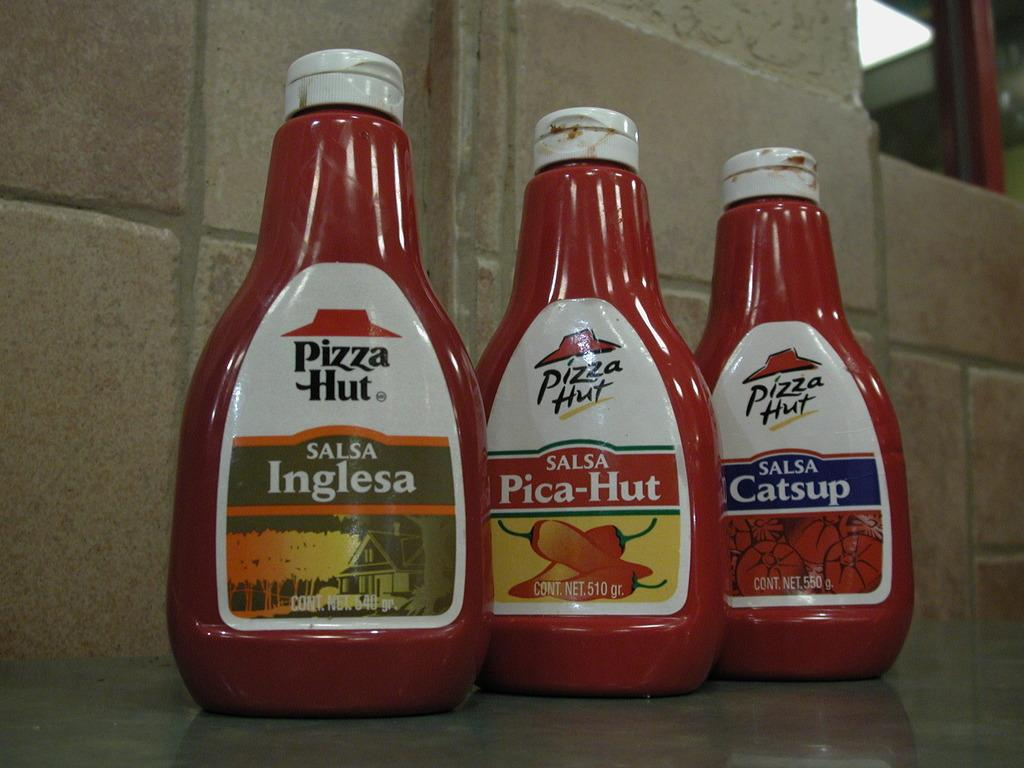Provide a one-sentence caption for the provided image. Several Pizza Hut products are bottled and labeled. 